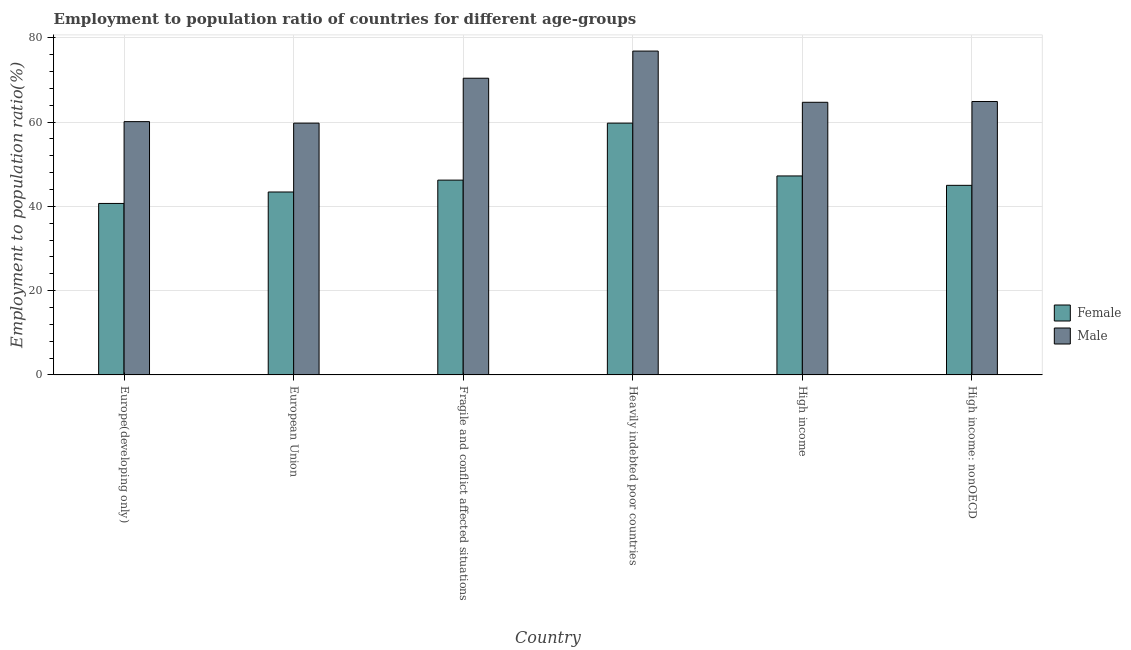How many different coloured bars are there?
Keep it short and to the point. 2. How many groups of bars are there?
Make the answer very short. 6. Are the number of bars per tick equal to the number of legend labels?
Keep it short and to the point. Yes. How many bars are there on the 2nd tick from the left?
Provide a succinct answer. 2. How many bars are there on the 4th tick from the right?
Keep it short and to the point. 2. What is the label of the 6th group of bars from the left?
Your response must be concise. High income: nonOECD. In how many cases, is the number of bars for a given country not equal to the number of legend labels?
Offer a terse response. 0. What is the employment to population ratio(male) in Europe(developing only)?
Offer a terse response. 60.09. Across all countries, what is the maximum employment to population ratio(female)?
Offer a very short reply. 59.74. Across all countries, what is the minimum employment to population ratio(male)?
Provide a succinct answer. 59.74. In which country was the employment to population ratio(female) maximum?
Offer a terse response. Heavily indebted poor countries. What is the total employment to population ratio(male) in the graph?
Offer a terse response. 396.6. What is the difference between the employment to population ratio(female) in Fragile and conflict affected situations and that in High income?
Give a very brief answer. -0.99. What is the difference between the employment to population ratio(male) in High income: nonOECD and the employment to population ratio(female) in Europe(developing only)?
Provide a short and direct response. 24.19. What is the average employment to population ratio(female) per country?
Your answer should be compact. 47.04. What is the difference between the employment to population ratio(male) and employment to population ratio(female) in High income: nonOECD?
Your answer should be very brief. 19.89. In how many countries, is the employment to population ratio(male) greater than 36 %?
Your response must be concise. 6. What is the ratio of the employment to population ratio(male) in Fragile and conflict affected situations to that in High income?
Offer a terse response. 1.09. Is the employment to population ratio(female) in European Union less than that in High income: nonOECD?
Your answer should be very brief. Yes. What is the difference between the highest and the second highest employment to population ratio(female)?
Give a very brief answer. 12.53. What is the difference between the highest and the lowest employment to population ratio(female)?
Your response must be concise. 19.06. In how many countries, is the employment to population ratio(female) greater than the average employment to population ratio(female) taken over all countries?
Provide a succinct answer. 2. What does the 1st bar from the left in Europe(developing only) represents?
Provide a succinct answer. Female. Are all the bars in the graph horizontal?
Provide a succinct answer. No. What is the difference between two consecutive major ticks on the Y-axis?
Your answer should be compact. 20. Does the graph contain any zero values?
Offer a very short reply. No. Where does the legend appear in the graph?
Give a very brief answer. Center right. How many legend labels are there?
Offer a terse response. 2. What is the title of the graph?
Provide a short and direct response. Employment to population ratio of countries for different age-groups. Does "Resident" appear as one of the legend labels in the graph?
Your response must be concise. No. What is the Employment to population ratio(%) in Female in Europe(developing only)?
Provide a succinct answer. 40.68. What is the Employment to population ratio(%) of Male in Europe(developing only)?
Give a very brief answer. 60.09. What is the Employment to population ratio(%) of Female in European Union?
Ensure brevity in your answer.  43.4. What is the Employment to population ratio(%) in Male in European Union?
Keep it short and to the point. 59.74. What is the Employment to population ratio(%) of Female in Fragile and conflict affected situations?
Provide a succinct answer. 46.22. What is the Employment to population ratio(%) of Male in Fragile and conflict affected situations?
Your answer should be very brief. 70.39. What is the Employment to population ratio(%) in Female in Heavily indebted poor countries?
Your answer should be very brief. 59.74. What is the Employment to population ratio(%) in Male in Heavily indebted poor countries?
Your response must be concise. 76.83. What is the Employment to population ratio(%) in Female in High income?
Make the answer very short. 47.2. What is the Employment to population ratio(%) of Male in High income?
Give a very brief answer. 64.68. What is the Employment to population ratio(%) of Female in High income: nonOECD?
Give a very brief answer. 44.98. What is the Employment to population ratio(%) of Male in High income: nonOECD?
Provide a short and direct response. 64.87. Across all countries, what is the maximum Employment to population ratio(%) of Female?
Give a very brief answer. 59.74. Across all countries, what is the maximum Employment to population ratio(%) in Male?
Your answer should be very brief. 76.83. Across all countries, what is the minimum Employment to population ratio(%) of Female?
Provide a short and direct response. 40.68. Across all countries, what is the minimum Employment to population ratio(%) in Male?
Your response must be concise. 59.74. What is the total Employment to population ratio(%) in Female in the graph?
Provide a succinct answer. 282.21. What is the total Employment to population ratio(%) of Male in the graph?
Offer a very short reply. 396.6. What is the difference between the Employment to population ratio(%) in Female in Europe(developing only) and that in European Union?
Offer a terse response. -2.72. What is the difference between the Employment to population ratio(%) in Male in Europe(developing only) and that in European Union?
Keep it short and to the point. 0.36. What is the difference between the Employment to population ratio(%) of Female in Europe(developing only) and that in Fragile and conflict affected situations?
Your answer should be very brief. -5.54. What is the difference between the Employment to population ratio(%) in Male in Europe(developing only) and that in Fragile and conflict affected situations?
Offer a terse response. -10.3. What is the difference between the Employment to population ratio(%) of Female in Europe(developing only) and that in Heavily indebted poor countries?
Your answer should be very brief. -19.06. What is the difference between the Employment to population ratio(%) in Male in Europe(developing only) and that in Heavily indebted poor countries?
Keep it short and to the point. -16.74. What is the difference between the Employment to population ratio(%) in Female in Europe(developing only) and that in High income?
Ensure brevity in your answer.  -6.52. What is the difference between the Employment to population ratio(%) of Male in Europe(developing only) and that in High income?
Your answer should be compact. -4.59. What is the difference between the Employment to population ratio(%) of Female in Europe(developing only) and that in High income: nonOECD?
Make the answer very short. -4.3. What is the difference between the Employment to population ratio(%) in Male in Europe(developing only) and that in High income: nonOECD?
Offer a terse response. -4.78. What is the difference between the Employment to population ratio(%) in Female in European Union and that in Fragile and conflict affected situations?
Ensure brevity in your answer.  -2.82. What is the difference between the Employment to population ratio(%) in Male in European Union and that in Fragile and conflict affected situations?
Offer a terse response. -10.66. What is the difference between the Employment to population ratio(%) in Female in European Union and that in Heavily indebted poor countries?
Your answer should be very brief. -16.34. What is the difference between the Employment to population ratio(%) of Male in European Union and that in Heavily indebted poor countries?
Your response must be concise. -17.1. What is the difference between the Employment to population ratio(%) of Female in European Union and that in High income?
Give a very brief answer. -3.81. What is the difference between the Employment to population ratio(%) of Male in European Union and that in High income?
Give a very brief answer. -4.94. What is the difference between the Employment to population ratio(%) of Female in European Union and that in High income: nonOECD?
Provide a short and direct response. -1.58. What is the difference between the Employment to population ratio(%) of Male in European Union and that in High income: nonOECD?
Provide a succinct answer. -5.13. What is the difference between the Employment to population ratio(%) of Female in Fragile and conflict affected situations and that in Heavily indebted poor countries?
Your response must be concise. -13.52. What is the difference between the Employment to population ratio(%) of Male in Fragile and conflict affected situations and that in Heavily indebted poor countries?
Keep it short and to the point. -6.44. What is the difference between the Employment to population ratio(%) of Female in Fragile and conflict affected situations and that in High income?
Your answer should be compact. -0.99. What is the difference between the Employment to population ratio(%) in Male in Fragile and conflict affected situations and that in High income?
Provide a short and direct response. 5.71. What is the difference between the Employment to population ratio(%) in Female in Fragile and conflict affected situations and that in High income: nonOECD?
Provide a succinct answer. 1.24. What is the difference between the Employment to population ratio(%) of Male in Fragile and conflict affected situations and that in High income: nonOECD?
Give a very brief answer. 5.52. What is the difference between the Employment to population ratio(%) of Female in Heavily indebted poor countries and that in High income?
Keep it short and to the point. 12.53. What is the difference between the Employment to population ratio(%) in Male in Heavily indebted poor countries and that in High income?
Provide a succinct answer. 12.15. What is the difference between the Employment to population ratio(%) in Female in Heavily indebted poor countries and that in High income: nonOECD?
Give a very brief answer. 14.76. What is the difference between the Employment to population ratio(%) of Male in Heavily indebted poor countries and that in High income: nonOECD?
Offer a very short reply. 11.96. What is the difference between the Employment to population ratio(%) in Female in High income and that in High income: nonOECD?
Provide a succinct answer. 2.23. What is the difference between the Employment to population ratio(%) in Male in High income and that in High income: nonOECD?
Provide a short and direct response. -0.19. What is the difference between the Employment to population ratio(%) in Female in Europe(developing only) and the Employment to population ratio(%) in Male in European Union?
Keep it short and to the point. -19.06. What is the difference between the Employment to population ratio(%) of Female in Europe(developing only) and the Employment to population ratio(%) of Male in Fragile and conflict affected situations?
Your response must be concise. -29.71. What is the difference between the Employment to population ratio(%) in Female in Europe(developing only) and the Employment to population ratio(%) in Male in Heavily indebted poor countries?
Keep it short and to the point. -36.15. What is the difference between the Employment to population ratio(%) in Female in Europe(developing only) and the Employment to population ratio(%) in Male in High income?
Keep it short and to the point. -24. What is the difference between the Employment to population ratio(%) in Female in Europe(developing only) and the Employment to population ratio(%) in Male in High income: nonOECD?
Give a very brief answer. -24.19. What is the difference between the Employment to population ratio(%) in Female in European Union and the Employment to population ratio(%) in Male in Fragile and conflict affected situations?
Your answer should be compact. -26.99. What is the difference between the Employment to population ratio(%) of Female in European Union and the Employment to population ratio(%) of Male in Heavily indebted poor countries?
Provide a succinct answer. -33.44. What is the difference between the Employment to population ratio(%) in Female in European Union and the Employment to population ratio(%) in Male in High income?
Keep it short and to the point. -21.28. What is the difference between the Employment to population ratio(%) in Female in European Union and the Employment to population ratio(%) in Male in High income: nonOECD?
Your response must be concise. -21.47. What is the difference between the Employment to population ratio(%) in Female in Fragile and conflict affected situations and the Employment to population ratio(%) in Male in Heavily indebted poor countries?
Offer a terse response. -30.62. What is the difference between the Employment to population ratio(%) in Female in Fragile and conflict affected situations and the Employment to population ratio(%) in Male in High income?
Ensure brevity in your answer.  -18.46. What is the difference between the Employment to population ratio(%) of Female in Fragile and conflict affected situations and the Employment to population ratio(%) of Male in High income: nonOECD?
Offer a very short reply. -18.65. What is the difference between the Employment to population ratio(%) of Female in Heavily indebted poor countries and the Employment to population ratio(%) of Male in High income?
Provide a succinct answer. -4.94. What is the difference between the Employment to population ratio(%) of Female in Heavily indebted poor countries and the Employment to population ratio(%) of Male in High income: nonOECD?
Your response must be concise. -5.13. What is the difference between the Employment to population ratio(%) of Female in High income and the Employment to population ratio(%) of Male in High income: nonOECD?
Your answer should be compact. -17.67. What is the average Employment to population ratio(%) of Female per country?
Your answer should be very brief. 47.04. What is the average Employment to population ratio(%) in Male per country?
Your response must be concise. 66.1. What is the difference between the Employment to population ratio(%) of Female and Employment to population ratio(%) of Male in Europe(developing only)?
Provide a short and direct response. -19.41. What is the difference between the Employment to population ratio(%) of Female and Employment to population ratio(%) of Male in European Union?
Ensure brevity in your answer.  -16.34. What is the difference between the Employment to population ratio(%) in Female and Employment to population ratio(%) in Male in Fragile and conflict affected situations?
Keep it short and to the point. -24.18. What is the difference between the Employment to population ratio(%) of Female and Employment to population ratio(%) of Male in Heavily indebted poor countries?
Make the answer very short. -17.1. What is the difference between the Employment to population ratio(%) of Female and Employment to population ratio(%) of Male in High income?
Your answer should be very brief. -17.48. What is the difference between the Employment to population ratio(%) of Female and Employment to population ratio(%) of Male in High income: nonOECD?
Your answer should be compact. -19.89. What is the ratio of the Employment to population ratio(%) in Female in Europe(developing only) to that in European Union?
Keep it short and to the point. 0.94. What is the ratio of the Employment to population ratio(%) in Female in Europe(developing only) to that in Fragile and conflict affected situations?
Offer a terse response. 0.88. What is the ratio of the Employment to population ratio(%) in Male in Europe(developing only) to that in Fragile and conflict affected situations?
Offer a terse response. 0.85. What is the ratio of the Employment to population ratio(%) in Female in Europe(developing only) to that in Heavily indebted poor countries?
Provide a succinct answer. 0.68. What is the ratio of the Employment to population ratio(%) in Male in Europe(developing only) to that in Heavily indebted poor countries?
Your response must be concise. 0.78. What is the ratio of the Employment to population ratio(%) in Female in Europe(developing only) to that in High income?
Keep it short and to the point. 0.86. What is the ratio of the Employment to population ratio(%) in Male in Europe(developing only) to that in High income?
Offer a very short reply. 0.93. What is the ratio of the Employment to population ratio(%) in Female in Europe(developing only) to that in High income: nonOECD?
Make the answer very short. 0.9. What is the ratio of the Employment to population ratio(%) of Male in Europe(developing only) to that in High income: nonOECD?
Keep it short and to the point. 0.93. What is the ratio of the Employment to population ratio(%) in Female in European Union to that in Fragile and conflict affected situations?
Your answer should be very brief. 0.94. What is the ratio of the Employment to population ratio(%) of Male in European Union to that in Fragile and conflict affected situations?
Offer a terse response. 0.85. What is the ratio of the Employment to population ratio(%) in Female in European Union to that in Heavily indebted poor countries?
Give a very brief answer. 0.73. What is the ratio of the Employment to population ratio(%) of Male in European Union to that in Heavily indebted poor countries?
Offer a very short reply. 0.78. What is the ratio of the Employment to population ratio(%) of Female in European Union to that in High income?
Make the answer very short. 0.92. What is the ratio of the Employment to population ratio(%) of Male in European Union to that in High income?
Provide a short and direct response. 0.92. What is the ratio of the Employment to population ratio(%) of Female in European Union to that in High income: nonOECD?
Offer a terse response. 0.96. What is the ratio of the Employment to population ratio(%) in Male in European Union to that in High income: nonOECD?
Your answer should be very brief. 0.92. What is the ratio of the Employment to population ratio(%) in Female in Fragile and conflict affected situations to that in Heavily indebted poor countries?
Your answer should be very brief. 0.77. What is the ratio of the Employment to population ratio(%) of Male in Fragile and conflict affected situations to that in Heavily indebted poor countries?
Your answer should be very brief. 0.92. What is the ratio of the Employment to population ratio(%) in Female in Fragile and conflict affected situations to that in High income?
Provide a succinct answer. 0.98. What is the ratio of the Employment to population ratio(%) in Male in Fragile and conflict affected situations to that in High income?
Provide a succinct answer. 1.09. What is the ratio of the Employment to population ratio(%) in Female in Fragile and conflict affected situations to that in High income: nonOECD?
Make the answer very short. 1.03. What is the ratio of the Employment to population ratio(%) of Male in Fragile and conflict affected situations to that in High income: nonOECD?
Ensure brevity in your answer.  1.09. What is the ratio of the Employment to population ratio(%) of Female in Heavily indebted poor countries to that in High income?
Provide a succinct answer. 1.27. What is the ratio of the Employment to population ratio(%) of Male in Heavily indebted poor countries to that in High income?
Your answer should be very brief. 1.19. What is the ratio of the Employment to population ratio(%) in Female in Heavily indebted poor countries to that in High income: nonOECD?
Ensure brevity in your answer.  1.33. What is the ratio of the Employment to population ratio(%) in Male in Heavily indebted poor countries to that in High income: nonOECD?
Provide a succinct answer. 1.18. What is the ratio of the Employment to population ratio(%) in Female in High income to that in High income: nonOECD?
Make the answer very short. 1.05. What is the difference between the highest and the second highest Employment to population ratio(%) of Female?
Offer a very short reply. 12.53. What is the difference between the highest and the second highest Employment to population ratio(%) in Male?
Your response must be concise. 6.44. What is the difference between the highest and the lowest Employment to population ratio(%) of Female?
Offer a terse response. 19.06. What is the difference between the highest and the lowest Employment to population ratio(%) in Male?
Your answer should be compact. 17.1. 